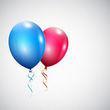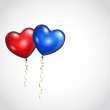The first image is the image on the left, the second image is the image on the right. Considering the images on both sides, is "There is a red and a blue balloon, and also some red and blue goop connected to each other." valid? Answer yes or no. No. The first image is the image on the left, the second image is the image on the right. Evaluate the accuracy of this statement regarding the images: "Exactly one image shows liquid-like side-by-side drops of blue and red.". Is it true? Answer yes or no. No. 